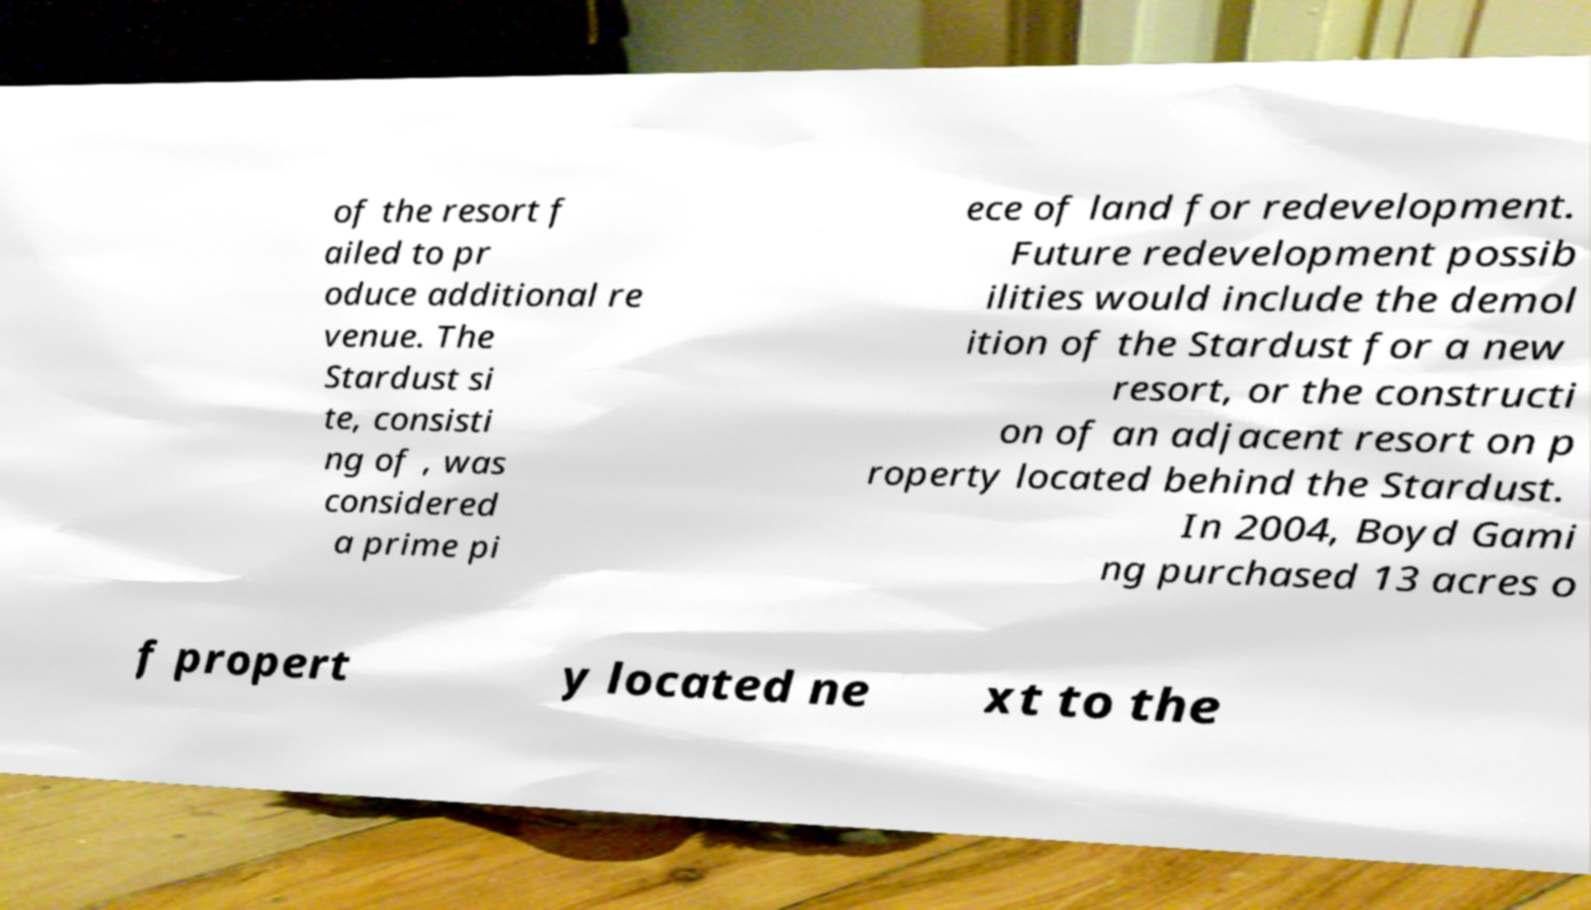Can you read and provide the text displayed in the image?This photo seems to have some interesting text. Can you extract and type it out for me? of the resort f ailed to pr oduce additional re venue. The Stardust si te, consisti ng of , was considered a prime pi ece of land for redevelopment. Future redevelopment possib ilities would include the demol ition of the Stardust for a new resort, or the constructi on of an adjacent resort on p roperty located behind the Stardust. In 2004, Boyd Gami ng purchased 13 acres o f propert y located ne xt to the 